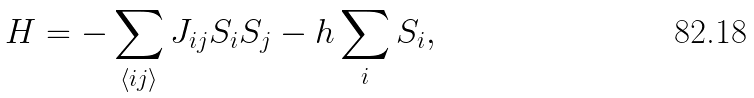Convert formula to latex. <formula><loc_0><loc_0><loc_500><loc_500>H = - \sum _ { \langle i j \rangle } J _ { i j } S _ { i } S _ { j } - h \sum _ { i } S _ { i } ,</formula> 